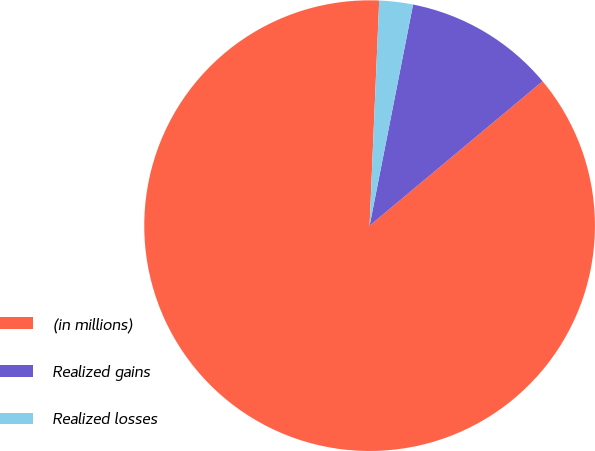Convert chart. <chart><loc_0><loc_0><loc_500><loc_500><pie_chart><fcel>(in millions)<fcel>Realized gains<fcel>Realized losses<nl><fcel>86.75%<fcel>10.84%<fcel>2.41%<nl></chart> 